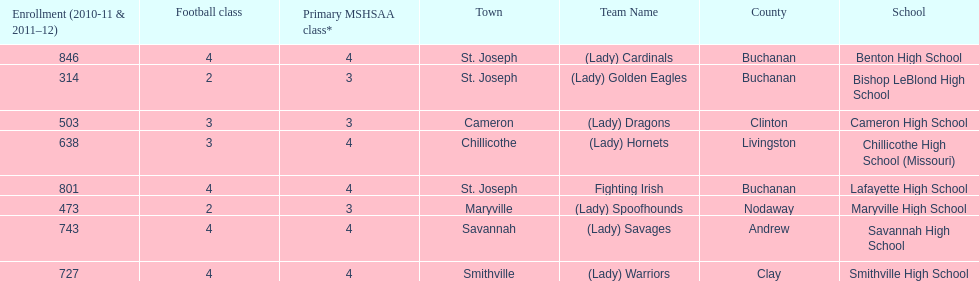Which schools are in the same town as bishop leblond? Benton High School, Lafayette High School. 